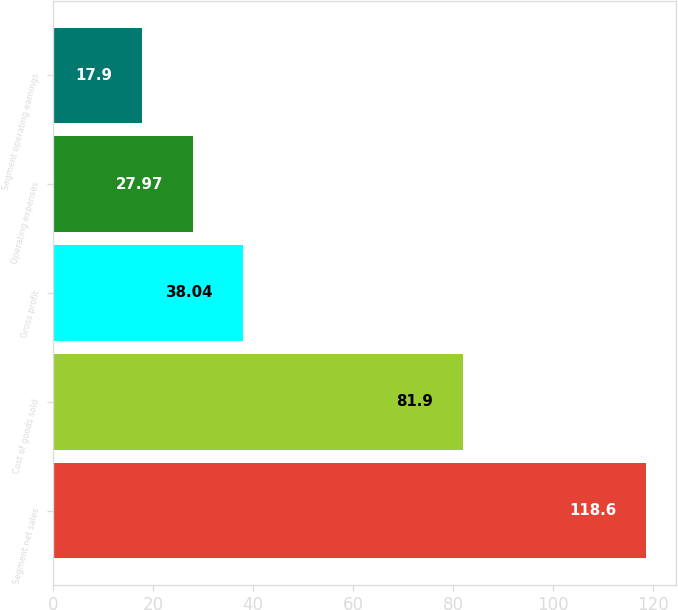<chart> <loc_0><loc_0><loc_500><loc_500><bar_chart><fcel>Segment net sales<fcel>Cost of goods sold<fcel>Gross profit<fcel>Operating expenses<fcel>Segment operating earnings<nl><fcel>118.6<fcel>81.9<fcel>38.04<fcel>27.97<fcel>17.9<nl></chart> 